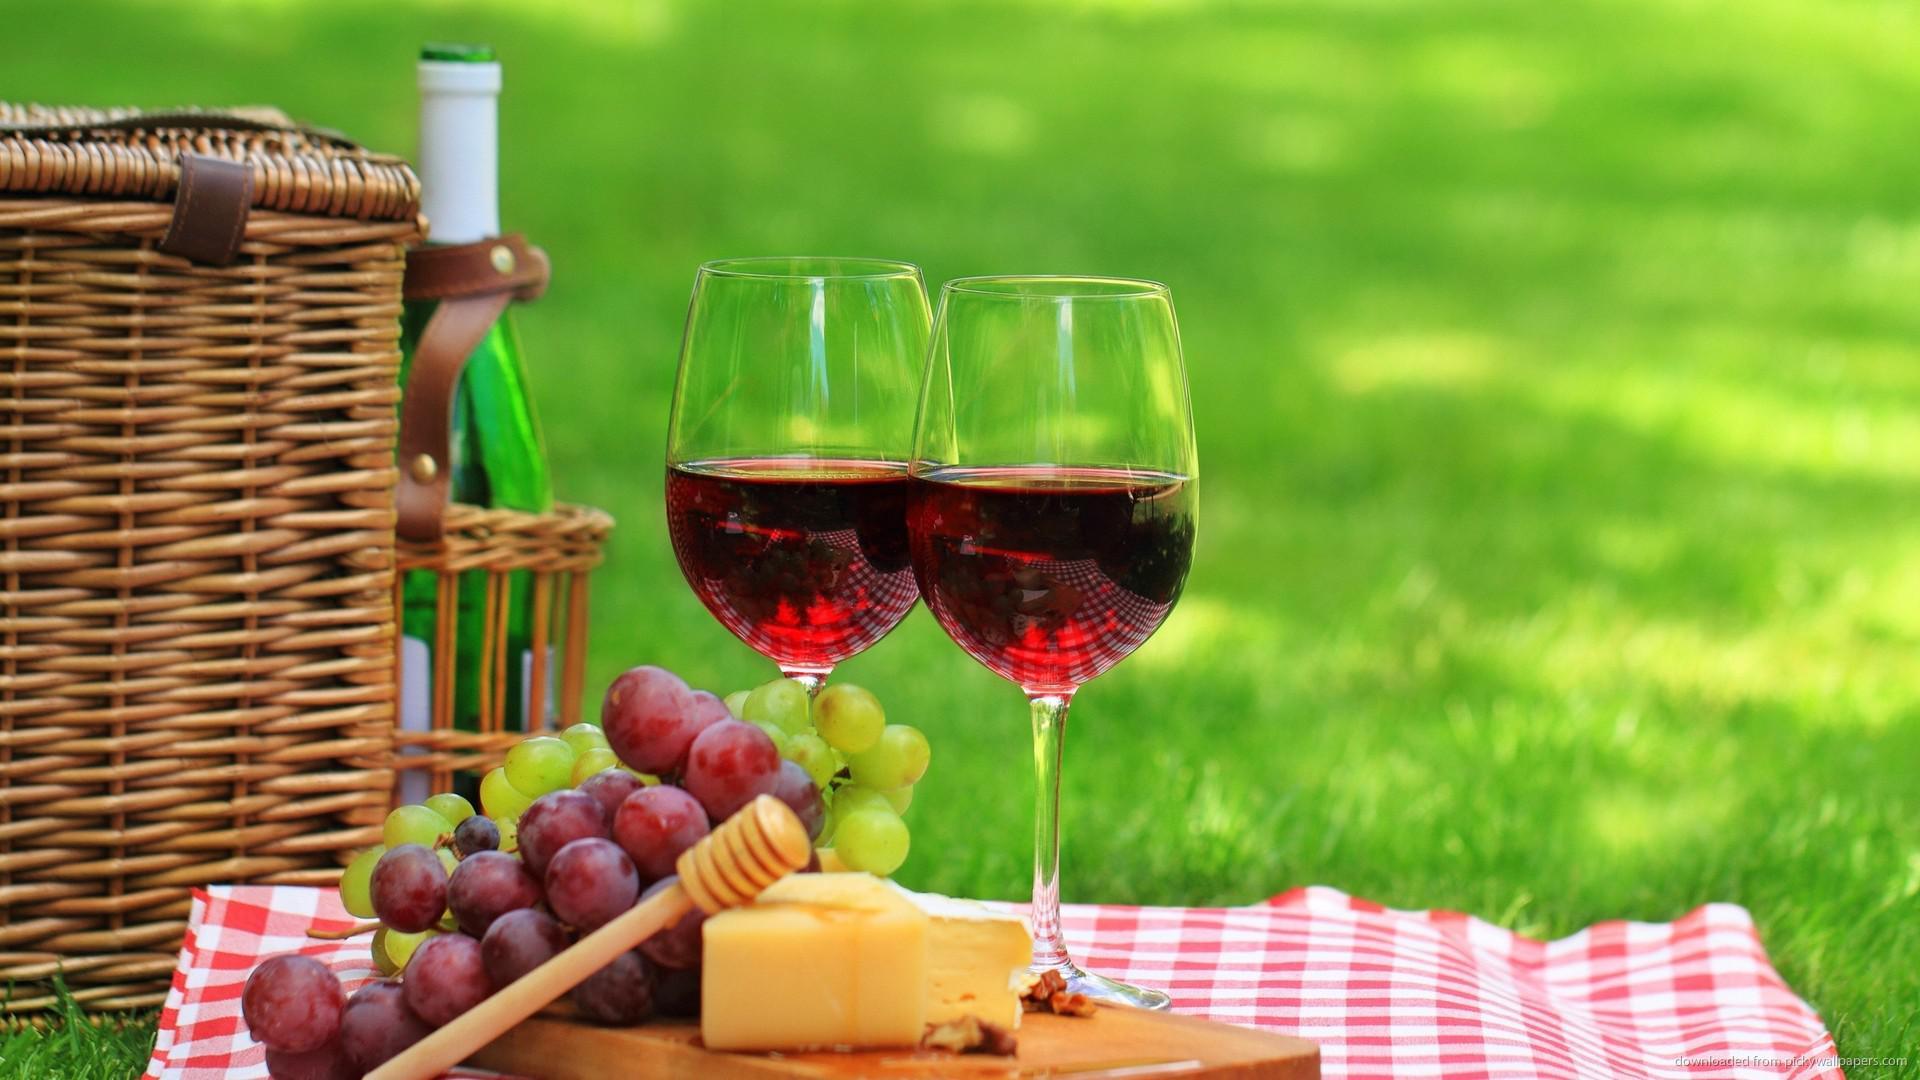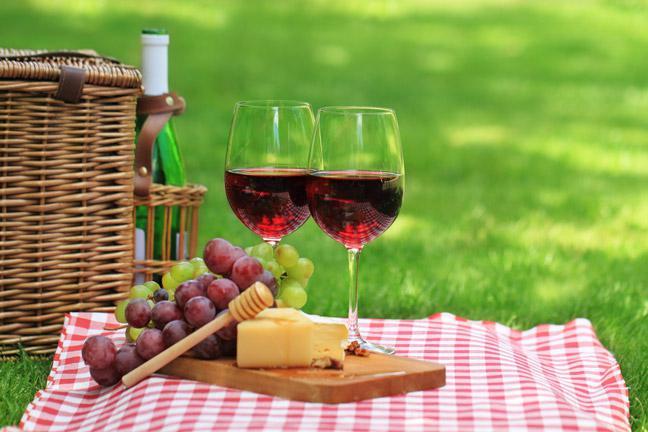The first image is the image on the left, the second image is the image on the right. Assess this claim about the two images: "The wine glasses are near wicker picnic baskets.". Correct or not? Answer yes or no. Yes. 